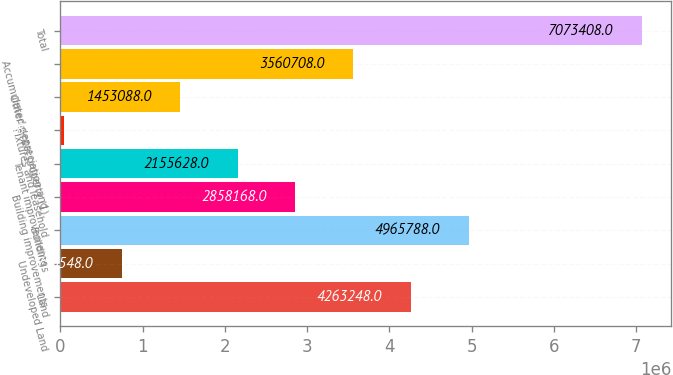Convert chart. <chart><loc_0><loc_0><loc_500><loc_500><bar_chart><fcel>Land<fcel>Undeveloped Land<fcel>Buildings<fcel>Building improvements<fcel>Tenant improvements<fcel>Fixtures and leasehold<fcel>Other rental property (1)<fcel>Accumulated depreciation and<fcel>Total<nl><fcel>4.26325e+06<fcel>750548<fcel>4.96579e+06<fcel>2.85817e+06<fcel>2.15563e+06<fcel>48008<fcel>1.45309e+06<fcel>3.56071e+06<fcel>7.07341e+06<nl></chart> 